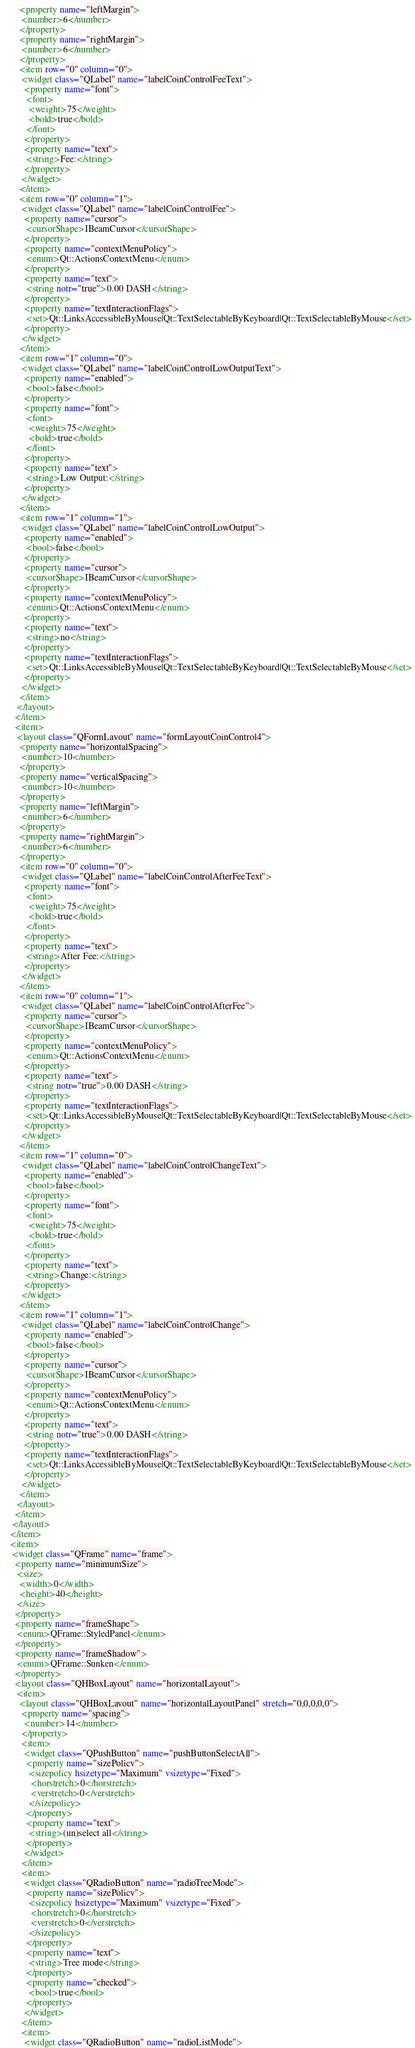Convert code to text. <code><loc_0><loc_0><loc_500><loc_500><_XML_>       <property name="leftMargin">
        <number>6</number>
       </property>
       <property name="rightMargin">
        <number>6</number>
       </property>
       <item row="0" column="0">
        <widget class="QLabel" name="labelCoinControlFeeText">
         <property name="font">
          <font>
           <weight>75</weight>
           <bold>true</bold>
          </font>
         </property>
         <property name="text">
          <string>Fee:</string>
         </property>
        </widget>
       </item>
       <item row="0" column="1">
        <widget class="QLabel" name="labelCoinControlFee">
         <property name="cursor">
          <cursorShape>IBeamCursor</cursorShape>
         </property>
         <property name="contextMenuPolicy">
          <enum>Qt::ActionsContextMenu</enum>
         </property>
         <property name="text">
          <string notr="true">0.00 DASH</string>
         </property>
         <property name="textInteractionFlags">
          <set>Qt::LinksAccessibleByMouse|Qt::TextSelectableByKeyboard|Qt::TextSelectableByMouse</set>
         </property>
        </widget>
       </item>
       <item row="1" column="0">
        <widget class="QLabel" name="labelCoinControlLowOutputText">
         <property name="enabled">
          <bool>false</bool>
         </property>
         <property name="font">
          <font>
           <weight>75</weight>
           <bold>true</bold>
          </font>
         </property>
         <property name="text">
          <string>Low Output:</string>
         </property>
        </widget>
       </item>
       <item row="1" column="1">
        <widget class="QLabel" name="labelCoinControlLowOutput">
         <property name="enabled">
          <bool>false</bool>
         </property>
         <property name="cursor">
          <cursorShape>IBeamCursor</cursorShape>
         </property>
         <property name="contextMenuPolicy">
          <enum>Qt::ActionsContextMenu</enum>
         </property>
         <property name="text">
          <string>no</string>
         </property>
         <property name="textInteractionFlags">
          <set>Qt::LinksAccessibleByMouse|Qt::TextSelectableByKeyboard|Qt::TextSelectableByMouse</set>
         </property>
        </widget>
       </item>
      </layout>
     </item>
     <item>
      <layout class="QFormLayout" name="formLayoutCoinControl4">
       <property name="horizontalSpacing">
        <number>10</number>
       </property>
       <property name="verticalSpacing">
        <number>10</number>
       </property>
       <property name="leftMargin">
        <number>6</number>
       </property>
       <property name="rightMargin">
        <number>6</number>
       </property>
       <item row="0" column="0">
        <widget class="QLabel" name="labelCoinControlAfterFeeText">
         <property name="font">
          <font>
           <weight>75</weight>
           <bold>true</bold>
          </font>
         </property>
         <property name="text">
          <string>After Fee:</string>
         </property>
        </widget>
       </item>
       <item row="0" column="1">
        <widget class="QLabel" name="labelCoinControlAfterFee">
         <property name="cursor">
          <cursorShape>IBeamCursor</cursorShape>
         </property>
         <property name="contextMenuPolicy">
          <enum>Qt::ActionsContextMenu</enum>
         </property>
         <property name="text">
          <string notr="true">0.00 DASH</string>
         </property>
         <property name="textInteractionFlags">
          <set>Qt::LinksAccessibleByMouse|Qt::TextSelectableByKeyboard|Qt::TextSelectableByMouse</set>
         </property>
        </widget>
       </item>
       <item row="1" column="0">
        <widget class="QLabel" name="labelCoinControlChangeText">
         <property name="enabled">
          <bool>false</bool>
         </property>
         <property name="font">
          <font>
           <weight>75</weight>
           <bold>true</bold>
          </font>
         </property>
         <property name="text">
          <string>Change:</string>
         </property>
        </widget>
       </item>
       <item row="1" column="1">
        <widget class="QLabel" name="labelCoinControlChange">
         <property name="enabled">
          <bool>false</bool>
         </property>
         <property name="cursor">
          <cursorShape>IBeamCursor</cursorShape>
         </property>
         <property name="contextMenuPolicy">
          <enum>Qt::ActionsContextMenu</enum>
         </property>
         <property name="text">
          <string notr="true">0.00 DASH</string>
         </property>
         <property name="textInteractionFlags">
          <set>Qt::LinksAccessibleByMouse|Qt::TextSelectableByKeyboard|Qt::TextSelectableByMouse</set>
         </property>
        </widget>
       </item>
      </layout>
     </item>
    </layout>
   </item>
   <item>
    <widget class="QFrame" name="frame">
     <property name="minimumSize">
      <size>
       <width>0</width>
       <height>40</height>
      </size>
     </property>
     <property name="frameShape">
      <enum>QFrame::StyledPanel</enum>
     </property>
     <property name="frameShadow">
      <enum>QFrame::Sunken</enum>
     </property>
     <layout class="QHBoxLayout" name="horizontalLayout">
      <item>
       <layout class="QHBoxLayout" name="horizontalLayoutPanel" stretch="0,0,0,0,0">
        <property name="spacing">
         <number>14</number>
        </property>
        <item>
         <widget class="QPushButton" name="pushButtonSelectAll">
          <property name="sizePolicy">
           <sizepolicy hsizetype="Maximum" vsizetype="Fixed">
            <horstretch>0</horstretch>
            <verstretch>0</verstretch>
           </sizepolicy>
          </property>
          <property name="text">
           <string>(un)select all</string>
          </property>
         </widget>
        </item>
        <item>
         <widget class="QRadioButton" name="radioTreeMode">
          <property name="sizePolicy">
           <sizepolicy hsizetype="Maximum" vsizetype="Fixed">
            <horstretch>0</horstretch>
            <verstretch>0</verstretch>
           </sizepolicy>
          </property>
          <property name="text">
           <string>Tree mode</string>
          </property>
          <property name="checked">
           <bool>true</bool>
          </property>
         </widget>
        </item>
        <item>
         <widget class="QRadioButton" name="radioListMode"></code> 